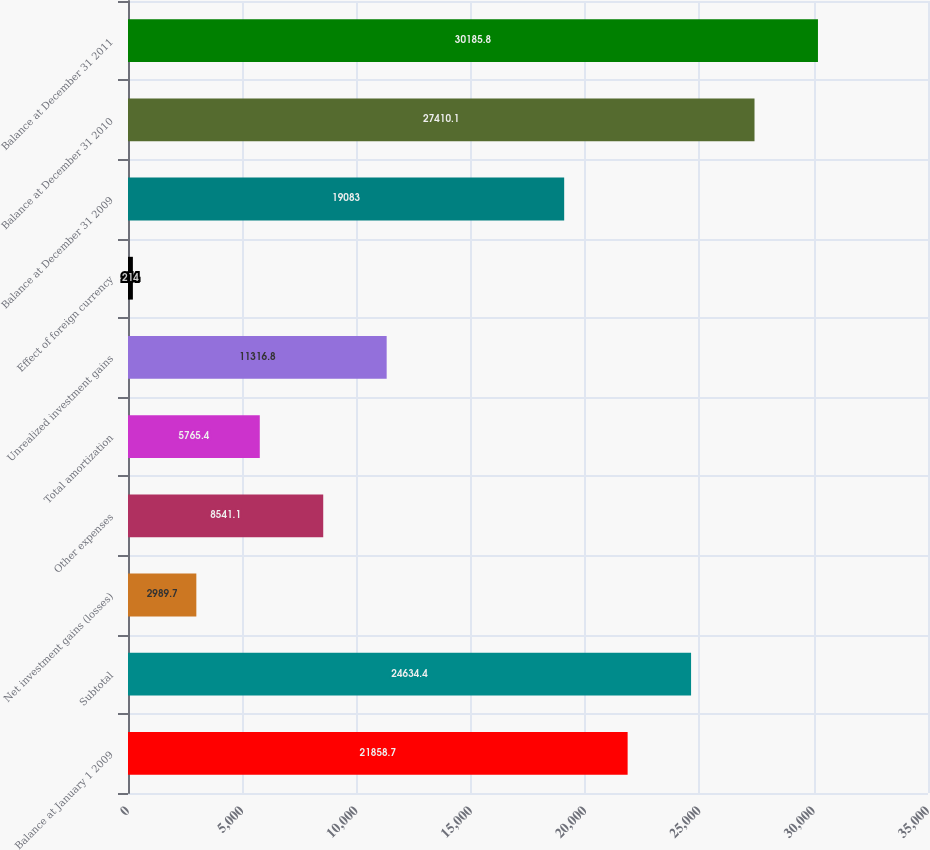Convert chart. <chart><loc_0><loc_0><loc_500><loc_500><bar_chart><fcel>Balance at January 1 2009<fcel>Subtotal<fcel>Net investment gains (losses)<fcel>Other expenses<fcel>Total amortization<fcel>Unrealized investment gains<fcel>Effect of foreign currency<fcel>Balance at December 31 2009<fcel>Balance at December 31 2010<fcel>Balance at December 31 2011<nl><fcel>21858.7<fcel>24634.4<fcel>2989.7<fcel>8541.1<fcel>5765.4<fcel>11316.8<fcel>214<fcel>19083<fcel>27410.1<fcel>30185.8<nl></chart> 